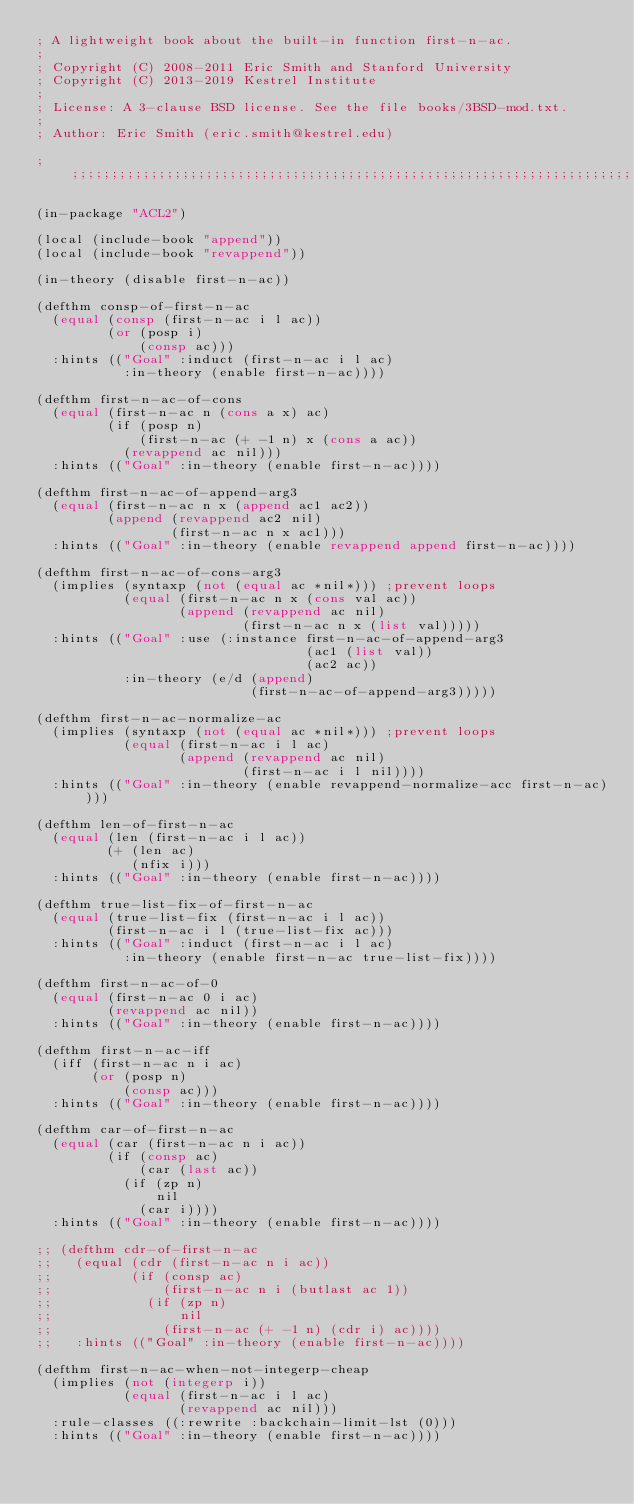Convert code to text. <code><loc_0><loc_0><loc_500><loc_500><_Lisp_>; A lightweight book about the built-in function first-n-ac.
;
; Copyright (C) 2008-2011 Eric Smith and Stanford University
; Copyright (C) 2013-2019 Kestrel Institute
;
; License: A 3-clause BSD license. See the file books/3BSD-mod.txt.
;
; Author: Eric Smith (eric.smith@kestrel.edu)

;;;;;;;;;;;;;;;;;;;;;;;;;;;;;;;;;;;;;;;;;;;;;;;;;;;;;;;;;;;;;;;;;;;;;;;;;;;;;;;;

(in-package "ACL2")

(local (include-book "append"))
(local (include-book "revappend"))

(in-theory (disable first-n-ac))

(defthm consp-of-first-n-ac
  (equal (consp (first-n-ac i l ac))
         (or (posp i)
             (consp ac)))
  :hints (("Goal" :induct (first-n-ac i l ac)
           :in-theory (enable first-n-ac))))

(defthm first-n-ac-of-cons
  (equal (first-n-ac n (cons a x) ac)
         (if (posp n)
             (first-n-ac (+ -1 n) x (cons a ac))
           (revappend ac nil)))
  :hints (("Goal" :in-theory (enable first-n-ac))))

(defthm first-n-ac-of-append-arg3
  (equal (first-n-ac n x (append ac1 ac2))
         (append (revappend ac2 nil)
                 (first-n-ac n x ac1)))
  :hints (("Goal" :in-theory (enable revappend append first-n-ac))))

(defthm first-n-ac-of-cons-arg3
  (implies (syntaxp (not (equal ac *nil*))) ;prevent loops
           (equal (first-n-ac n x (cons val ac))
                  (append (revappend ac nil)
                          (first-n-ac n x (list val)))))
  :hints (("Goal" :use (:instance first-n-ac-of-append-arg3
                                  (ac1 (list val))
                                  (ac2 ac))
           :in-theory (e/d (append)
                           (first-n-ac-of-append-arg3)))))

(defthm first-n-ac-normalize-ac
  (implies (syntaxp (not (equal ac *nil*))) ;prevent loops
           (equal (first-n-ac i l ac)
                  (append (revappend ac nil)
                          (first-n-ac i l nil))))
  :hints (("Goal" :in-theory (enable revappend-normalize-acc first-n-ac))))

(defthm len-of-first-n-ac
  (equal (len (first-n-ac i l ac))
         (+ (len ac)
            (nfix i)))
  :hints (("Goal" :in-theory (enable first-n-ac))))

(defthm true-list-fix-of-first-n-ac
  (equal (true-list-fix (first-n-ac i l ac))
         (first-n-ac i l (true-list-fix ac)))
  :hints (("Goal" :induct (first-n-ac i l ac)
           :in-theory (enable first-n-ac true-list-fix))))

(defthm first-n-ac-of-0
  (equal (first-n-ac 0 i ac)
         (revappend ac nil))
  :hints (("Goal" :in-theory (enable first-n-ac))))

(defthm first-n-ac-iff
  (iff (first-n-ac n i ac)
       (or (posp n)
           (consp ac)))
  :hints (("Goal" :in-theory (enable first-n-ac))))

(defthm car-of-first-n-ac
  (equal (car (first-n-ac n i ac))
         (if (consp ac)
             (car (last ac))
           (if (zp n)
               nil
             (car i))))
  :hints (("Goal" :in-theory (enable first-n-ac))))

;; (defthm cdr-of-first-n-ac
;;   (equal (cdr (first-n-ac n i ac))
;;          (if (consp ac)
;;              (first-n-ac n i (butlast ac 1))
;;            (if (zp n)
;;                nil
;;              (first-n-ac (+ -1 n) (cdr i) ac))))
;;   :hints (("Goal" :in-theory (enable first-n-ac))))

(defthm first-n-ac-when-not-integerp-cheap
  (implies (not (integerp i))
           (equal (first-n-ac i l ac)
                  (revappend ac nil)))
  :rule-classes ((:rewrite :backchain-limit-lst (0)))
  :hints (("Goal" :in-theory (enable first-n-ac))))
</code> 